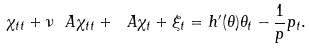Convert formula to latex. <formula><loc_0><loc_0><loc_500><loc_500>\chi _ { t t } + \nu \ A \chi _ { t t } + \ A \chi _ { t } + \xi _ { t } = h ^ { \prime } ( \theta ) \theta _ { t } - \frac { 1 } { p } p _ { t } .</formula> 